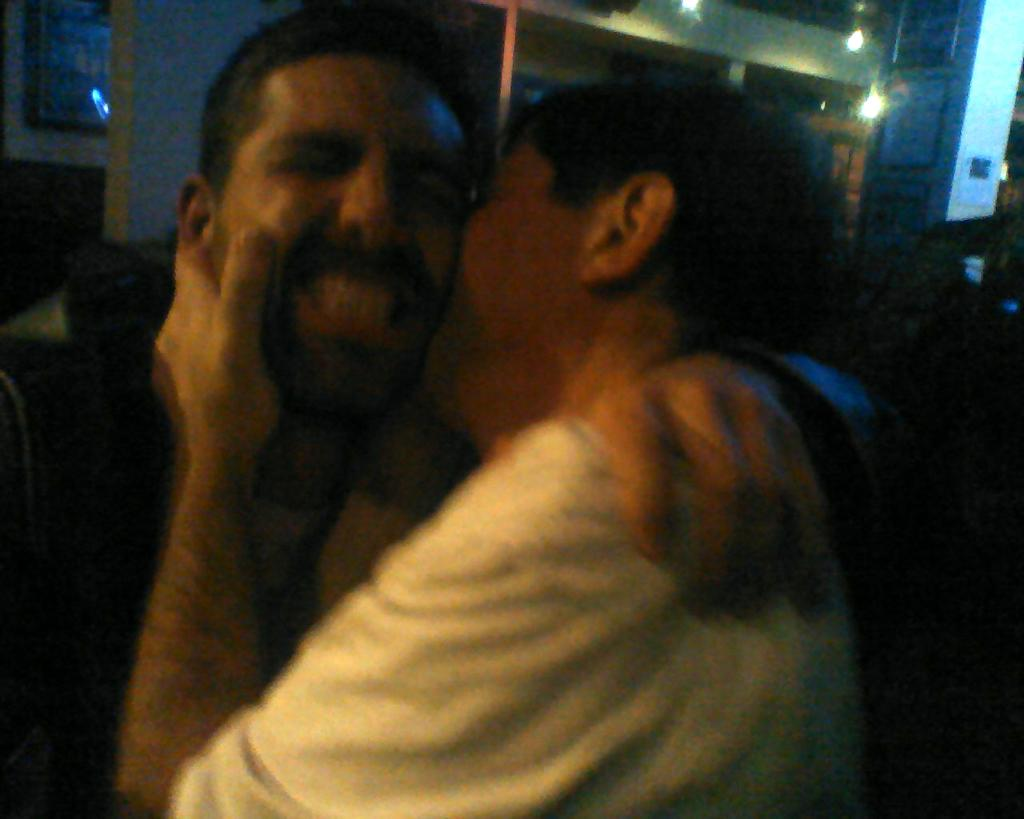What is happening between the two people in the image? There is a person holding another person in the image. What can be seen in the background of the image? There are walls, frames, lights, a pillar, and other objects visible in the background of the image. Can you hear a whistle in the image? There is no mention of a whistle in the image, so it cannot be heard. 